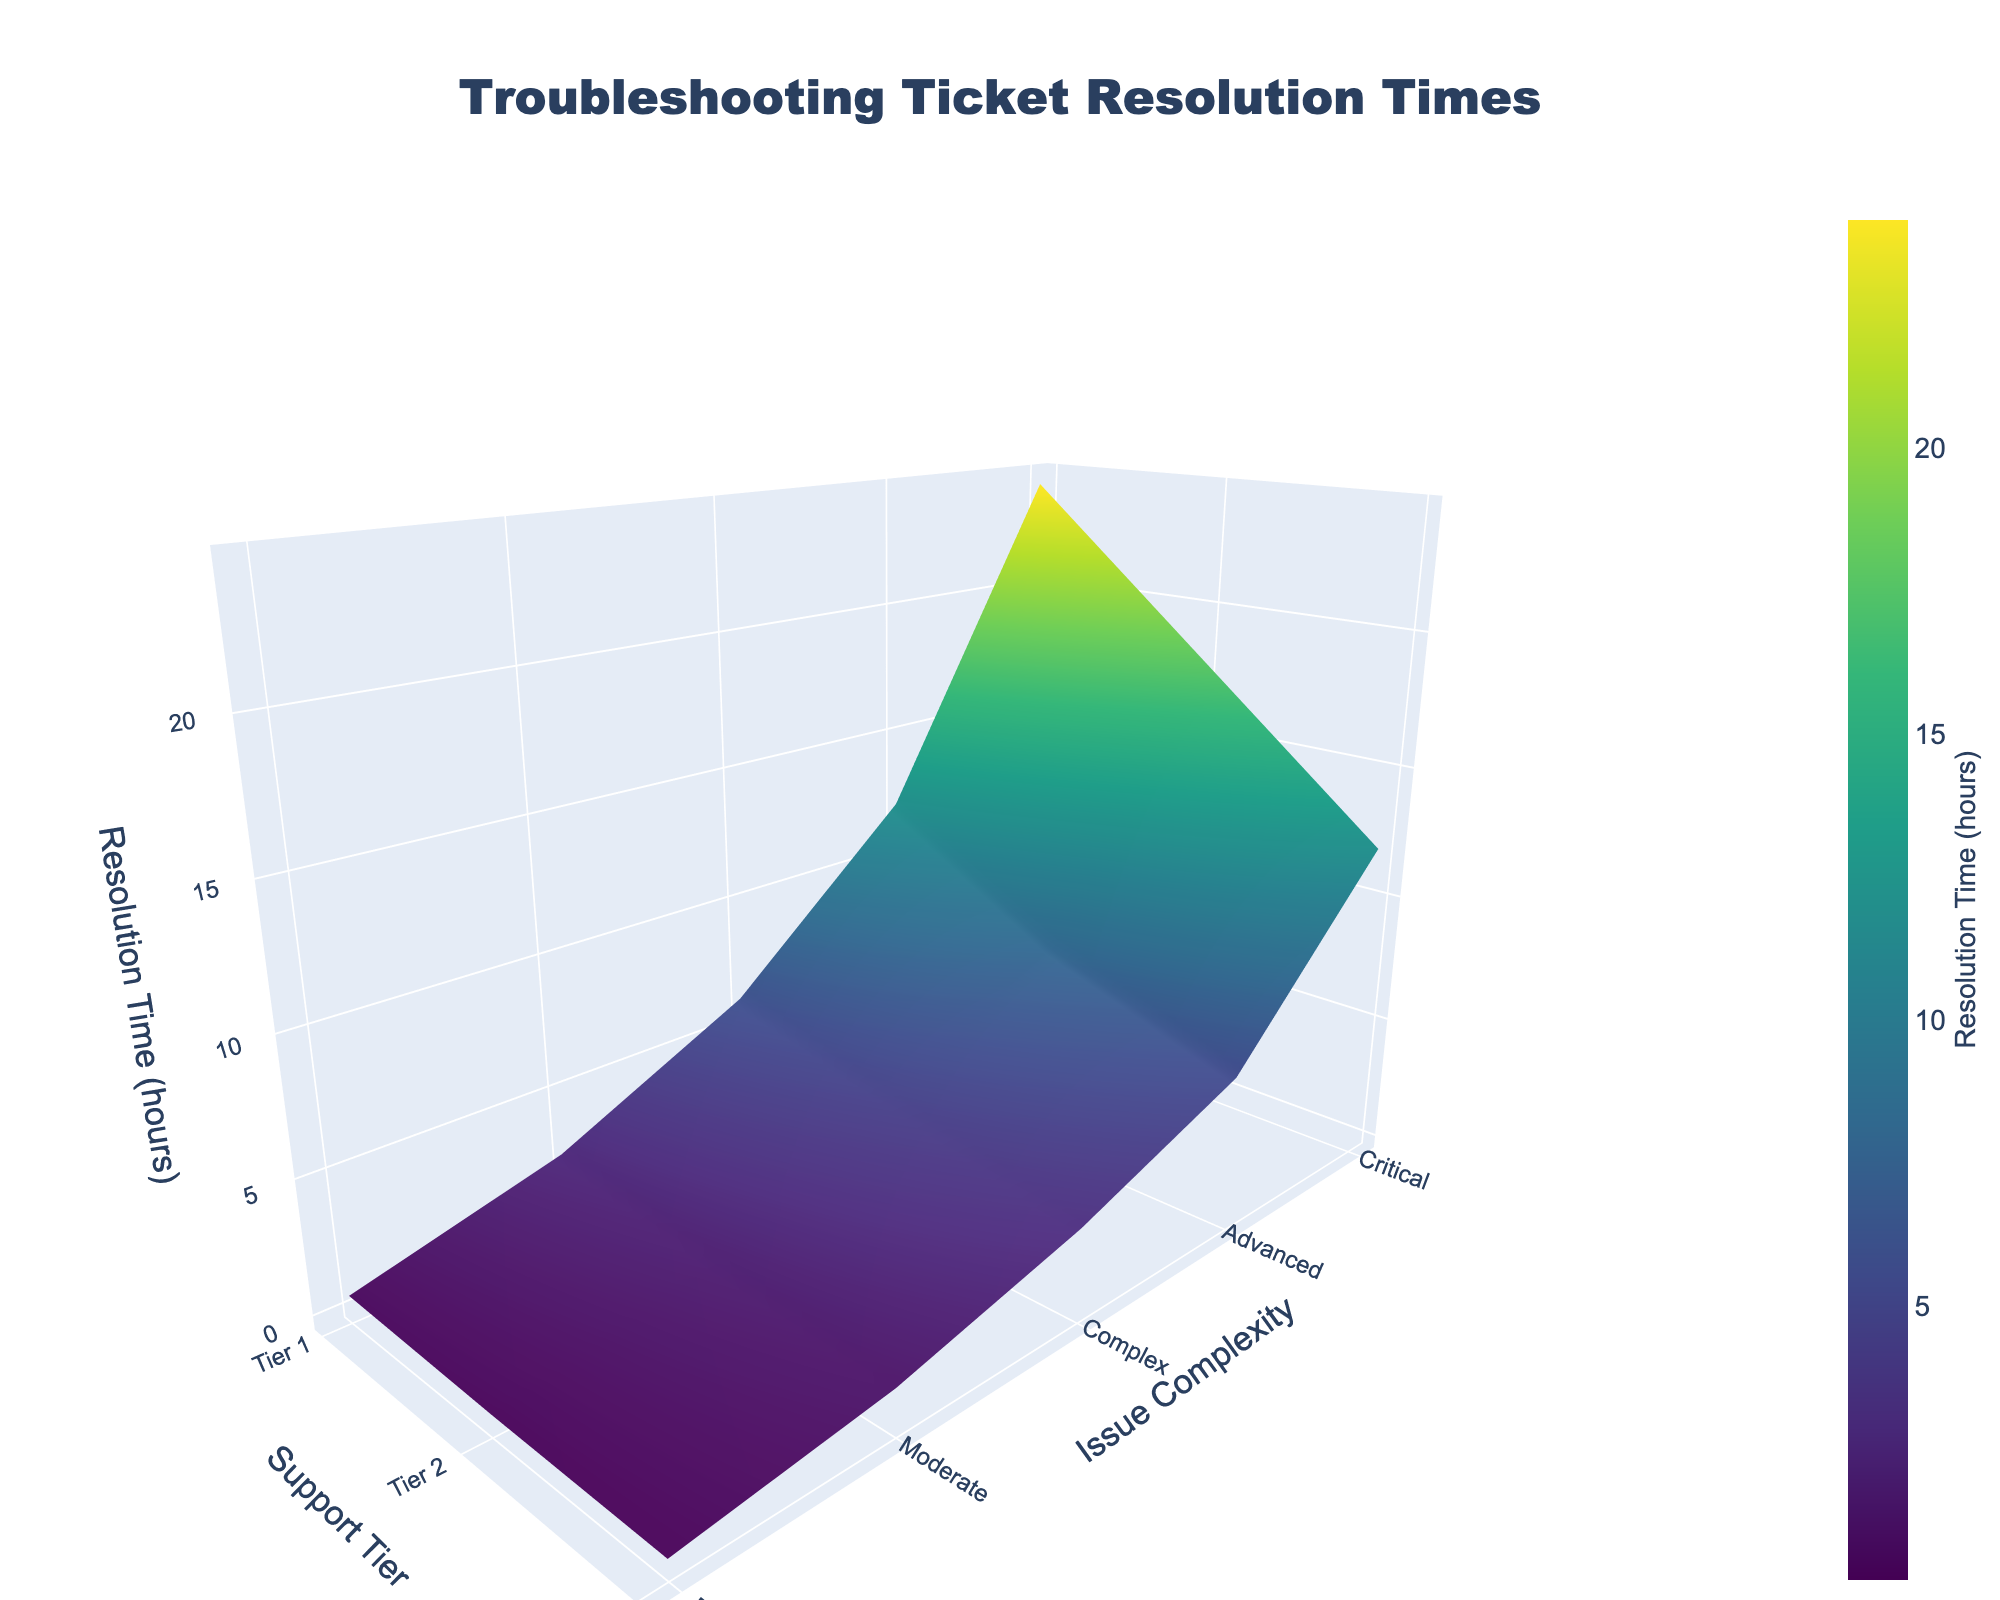What is the title of the plot? The title is prominently displayed at the top of the plot. It reads "Troubleshooting Ticket Resolution Times".
Answer: Troubleshooting Ticket Resolution Times Which axis represents the support tier levels? The x-axis at the bottom of the plot represents the support tier levels. It is labeled "Support Tier".
Answer: x-axis What is the maximum resolution time shown on the plot and for which issue complexity and support tier does it occur? The maximum resolution time is 24 hours, which occurs for a Critical issue addressed by Tier 1 support.
Answer: 24 hours for Critical issue at Tier 1 How does the resolution time change as the issue complexity increases from Basic to Critical for Tier 3 support? As the issue complexity increases from Basic to Critical for Tier 3 support, the resolution time also increases. From 0.2 hours (Basic), to 1.2 hours (Moderate), 3.0 hours (Complex), 5.5 hours (Advanced), and finally 12.0 hours (Critical).
Answer: Increases progressively How does the resolution time for Critical issues vary across different support tiers? The resolution time for Critical issues varies significantly across different support tiers. It is 24 hours for Tier 1, 18 hours for Tier 2, and 12 hours for Tier 3.
Answer: 24 hours (Tier 1), 18 hours (Tier 2), 12 hours (Tier 3) Which support tier has the shortest average resolution time across all issue complexities? To find the shortest average resolution time, calculate the average for each support tier: Tier 1 (9.0 hours), Tier 2 (6.52 hours), Tier 3 (4.38 hours). Thus, Tier 3 has the shortest average resolution time.
Answer: Tier 3 For an Advanced issue, how much faster is the resolution time for Tier 2 compared to Tier 1? The resolution time for an Advanced issue is 12.0 hours for Tier 1 and 8.0 hours for Tier 2. Calculate the difference: 12.0 - 8.0 = 4.0 hours.
Answer: 4.0 hours faster What is the total resolution time for all Basic and Complex issues combined, when handled by Tier 2 support? Sum the resolution times for Basic and Complex issues at Tier 2: Basic (0.3 hours) + Complex (4.5 hours) = 4.8 hours.
Answer: 4.8 hours 